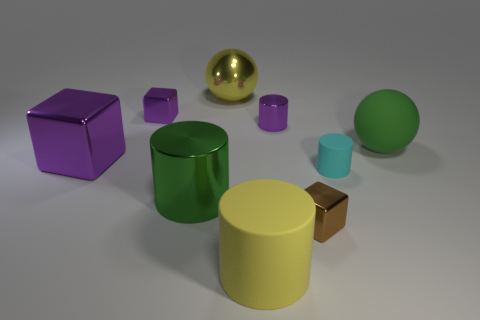The small cylinder that is behind the large cube behind the block that is in front of the large block is made of what material?
Provide a succinct answer. Metal. Do the small brown object and the small cylinder that is in front of the big rubber ball have the same material?
Your answer should be very brief. No. There is a big object that is the same shape as the small brown metal object; what is it made of?
Your response must be concise. Metal. Is the number of small blocks behind the green matte sphere greater than the number of large purple cubes to the right of the large yellow cylinder?
Provide a succinct answer. Yes. The large purple object that is made of the same material as the yellow sphere is what shape?
Your answer should be very brief. Cube. What number of other things are the same shape as the big yellow matte thing?
Make the answer very short. 3. The large yellow object behind the big purple metallic cube has what shape?
Give a very brief answer. Sphere. The rubber ball is what color?
Give a very brief answer. Green. What number of other things are the same size as the metallic sphere?
Make the answer very short. 4. There is a green object on the right side of the large rubber thing in front of the green sphere; what is its material?
Ensure brevity in your answer.  Rubber. 